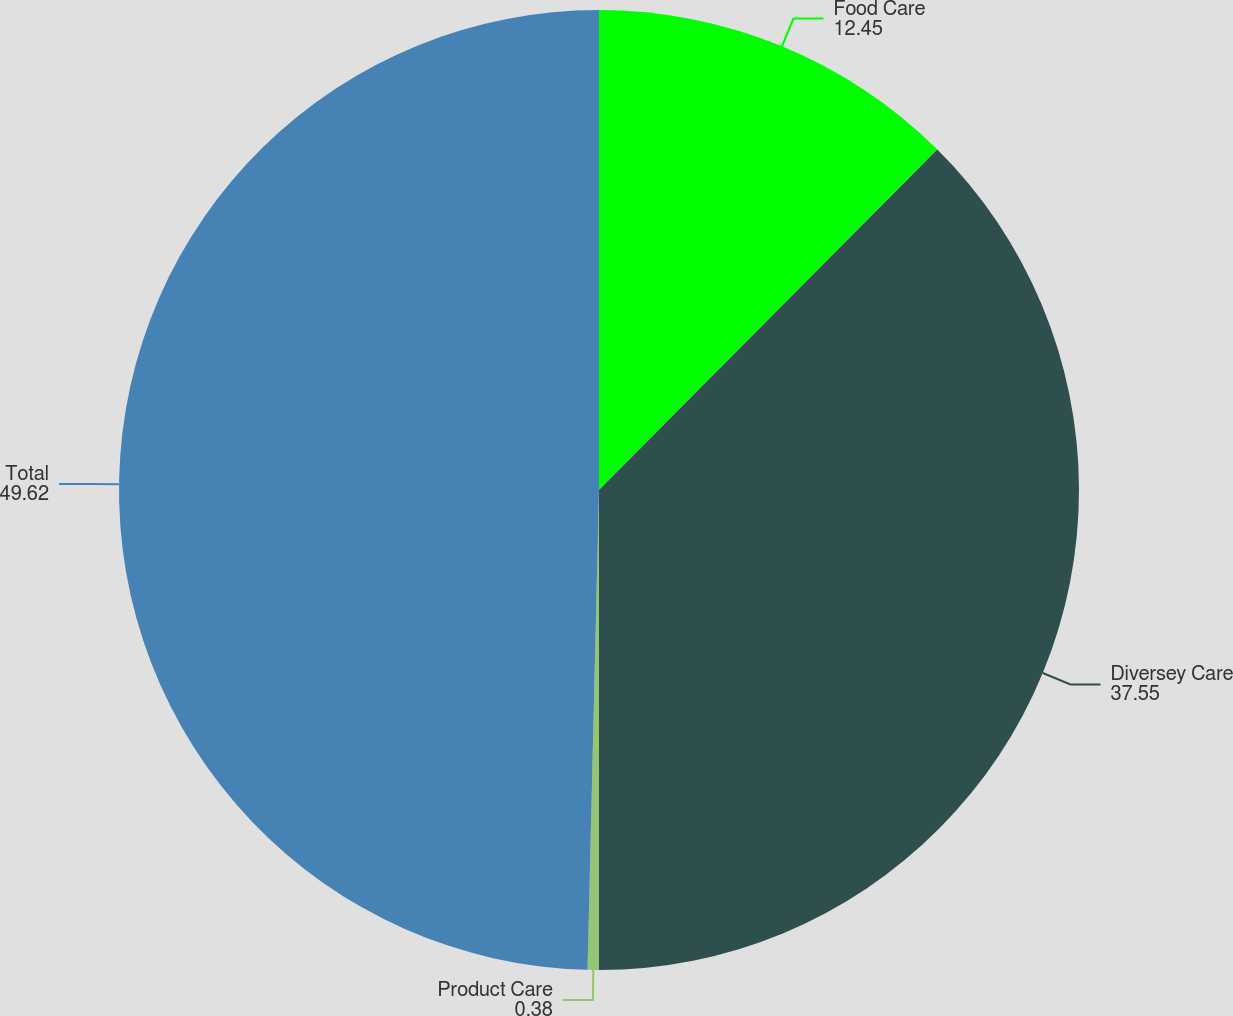Convert chart to OTSL. <chart><loc_0><loc_0><loc_500><loc_500><pie_chart><fcel>Food Care<fcel>Diversey Care<fcel>Product Care<fcel>Total<nl><fcel>12.45%<fcel>37.55%<fcel>0.38%<fcel>49.62%<nl></chart> 